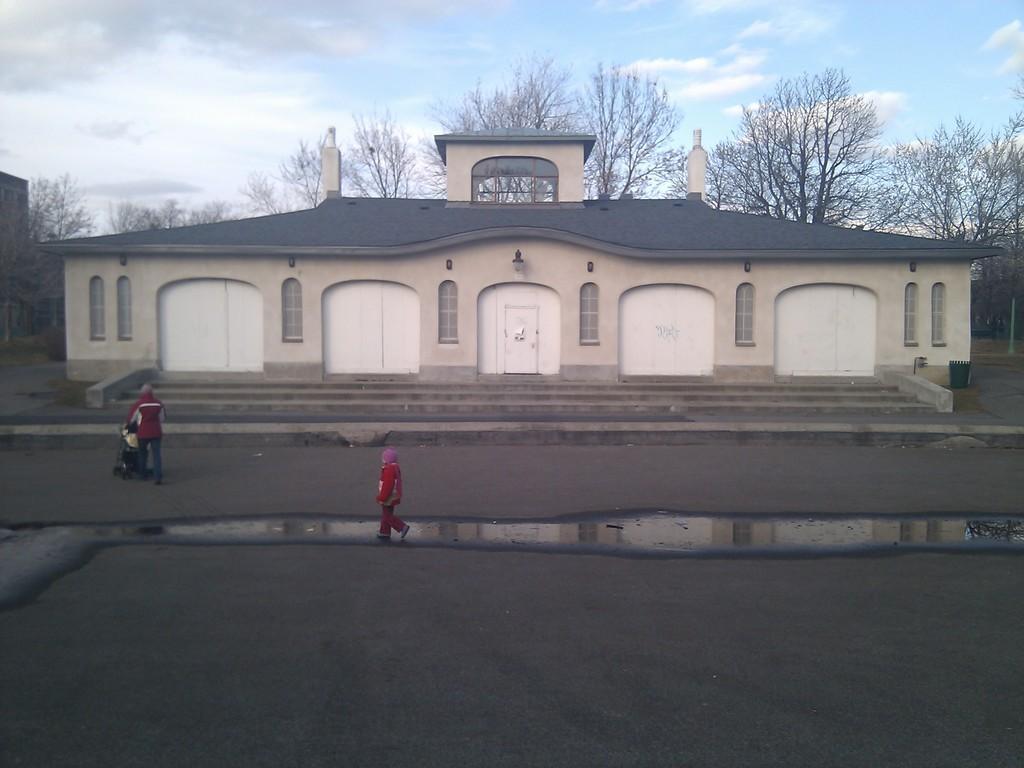Please provide a concise description of this image. In this image in the center there is one house and trees, at the bottom there is a road and some people are walking and also there are some stairs. On the top of the image there is sky. 